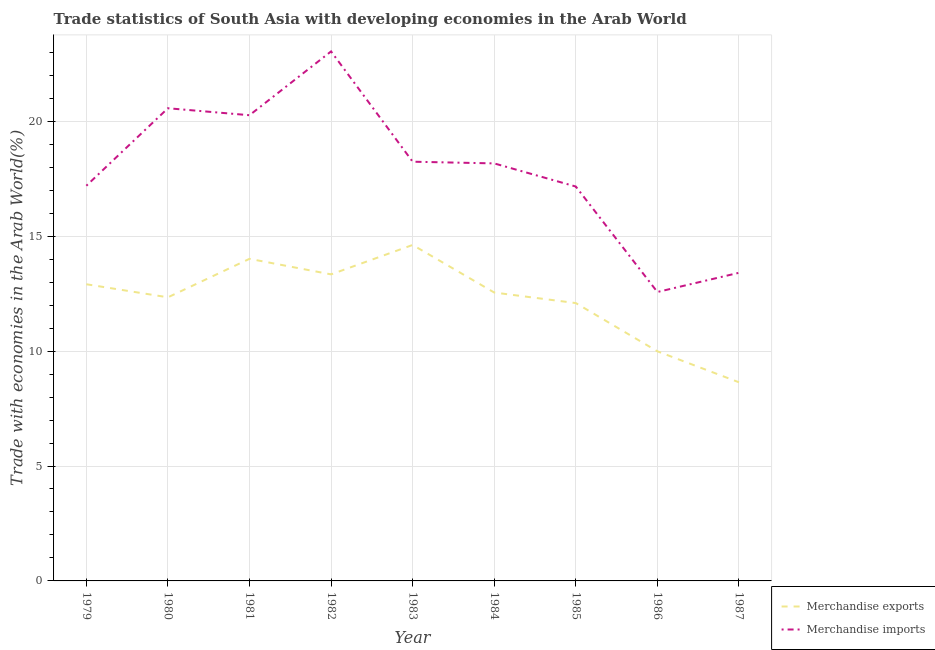Does the line corresponding to merchandise exports intersect with the line corresponding to merchandise imports?
Make the answer very short. No. Is the number of lines equal to the number of legend labels?
Your response must be concise. Yes. What is the merchandise imports in 1986?
Offer a very short reply. 12.57. Across all years, what is the maximum merchandise exports?
Ensure brevity in your answer.  14.62. Across all years, what is the minimum merchandise imports?
Offer a very short reply. 12.57. In which year was the merchandise exports minimum?
Your answer should be compact. 1987. What is the total merchandise imports in the graph?
Provide a succinct answer. 160.62. What is the difference between the merchandise exports in 1979 and that in 1984?
Offer a terse response. 0.36. What is the difference between the merchandise imports in 1985 and the merchandise exports in 1984?
Provide a succinct answer. 4.61. What is the average merchandise imports per year?
Keep it short and to the point. 17.85. In the year 1986, what is the difference between the merchandise exports and merchandise imports?
Ensure brevity in your answer.  -2.58. What is the ratio of the merchandise exports in 1984 to that in 1985?
Make the answer very short. 1.04. Is the merchandise exports in 1981 less than that in 1985?
Your answer should be very brief. No. What is the difference between the highest and the second highest merchandise imports?
Offer a very short reply. 2.47. What is the difference between the highest and the lowest merchandise exports?
Offer a very short reply. 5.98. In how many years, is the merchandise imports greater than the average merchandise imports taken over all years?
Provide a succinct answer. 5. Is the sum of the merchandise exports in 1981 and 1983 greater than the maximum merchandise imports across all years?
Offer a terse response. Yes. Is the merchandise exports strictly greater than the merchandise imports over the years?
Give a very brief answer. No. Is the merchandise exports strictly less than the merchandise imports over the years?
Your answer should be very brief. Yes. Are the values on the major ticks of Y-axis written in scientific E-notation?
Your response must be concise. No. What is the title of the graph?
Your response must be concise. Trade statistics of South Asia with developing economies in the Arab World. What is the label or title of the Y-axis?
Offer a terse response. Trade with economies in the Arab World(%). What is the Trade with economies in the Arab World(%) of Merchandise exports in 1979?
Provide a short and direct response. 12.91. What is the Trade with economies in the Arab World(%) of Merchandise imports in 1979?
Ensure brevity in your answer.  17.2. What is the Trade with economies in the Arab World(%) in Merchandise exports in 1980?
Provide a succinct answer. 12.34. What is the Trade with economies in the Arab World(%) in Merchandise imports in 1980?
Offer a terse response. 20.57. What is the Trade with economies in the Arab World(%) in Merchandise exports in 1981?
Provide a short and direct response. 14.02. What is the Trade with economies in the Arab World(%) of Merchandise imports in 1981?
Your answer should be compact. 20.26. What is the Trade with economies in the Arab World(%) in Merchandise exports in 1982?
Your answer should be compact. 13.34. What is the Trade with economies in the Arab World(%) of Merchandise imports in 1982?
Your response must be concise. 23.04. What is the Trade with economies in the Arab World(%) in Merchandise exports in 1983?
Provide a short and direct response. 14.62. What is the Trade with economies in the Arab World(%) of Merchandise imports in 1983?
Keep it short and to the point. 18.24. What is the Trade with economies in the Arab World(%) in Merchandise exports in 1984?
Your answer should be very brief. 12.55. What is the Trade with economies in the Arab World(%) in Merchandise imports in 1984?
Provide a short and direct response. 18.17. What is the Trade with economies in the Arab World(%) in Merchandise exports in 1985?
Your answer should be very brief. 12.09. What is the Trade with economies in the Arab World(%) of Merchandise imports in 1985?
Your response must be concise. 17.16. What is the Trade with economies in the Arab World(%) of Merchandise exports in 1986?
Your answer should be compact. 9.99. What is the Trade with economies in the Arab World(%) of Merchandise imports in 1986?
Offer a very short reply. 12.57. What is the Trade with economies in the Arab World(%) in Merchandise exports in 1987?
Ensure brevity in your answer.  8.64. What is the Trade with economies in the Arab World(%) of Merchandise imports in 1987?
Keep it short and to the point. 13.41. Across all years, what is the maximum Trade with economies in the Arab World(%) of Merchandise exports?
Your answer should be compact. 14.62. Across all years, what is the maximum Trade with economies in the Arab World(%) of Merchandise imports?
Provide a short and direct response. 23.04. Across all years, what is the minimum Trade with economies in the Arab World(%) of Merchandise exports?
Your answer should be compact. 8.64. Across all years, what is the minimum Trade with economies in the Arab World(%) of Merchandise imports?
Make the answer very short. 12.57. What is the total Trade with economies in the Arab World(%) in Merchandise exports in the graph?
Your response must be concise. 110.5. What is the total Trade with economies in the Arab World(%) in Merchandise imports in the graph?
Offer a very short reply. 160.62. What is the difference between the Trade with economies in the Arab World(%) in Merchandise exports in 1979 and that in 1980?
Your response must be concise. 0.57. What is the difference between the Trade with economies in the Arab World(%) of Merchandise imports in 1979 and that in 1980?
Offer a terse response. -3.37. What is the difference between the Trade with economies in the Arab World(%) of Merchandise exports in 1979 and that in 1981?
Your response must be concise. -1.11. What is the difference between the Trade with economies in the Arab World(%) in Merchandise imports in 1979 and that in 1981?
Offer a very short reply. -3.07. What is the difference between the Trade with economies in the Arab World(%) in Merchandise exports in 1979 and that in 1982?
Provide a succinct answer. -0.43. What is the difference between the Trade with economies in the Arab World(%) of Merchandise imports in 1979 and that in 1982?
Ensure brevity in your answer.  -5.85. What is the difference between the Trade with economies in the Arab World(%) of Merchandise exports in 1979 and that in 1983?
Your answer should be compact. -1.71. What is the difference between the Trade with economies in the Arab World(%) of Merchandise imports in 1979 and that in 1983?
Give a very brief answer. -1.05. What is the difference between the Trade with economies in the Arab World(%) in Merchandise exports in 1979 and that in 1984?
Your answer should be very brief. 0.36. What is the difference between the Trade with economies in the Arab World(%) in Merchandise imports in 1979 and that in 1984?
Make the answer very short. -0.97. What is the difference between the Trade with economies in the Arab World(%) in Merchandise exports in 1979 and that in 1985?
Your answer should be very brief. 0.82. What is the difference between the Trade with economies in the Arab World(%) in Merchandise imports in 1979 and that in 1985?
Give a very brief answer. 0.03. What is the difference between the Trade with economies in the Arab World(%) in Merchandise exports in 1979 and that in 1986?
Give a very brief answer. 2.92. What is the difference between the Trade with economies in the Arab World(%) in Merchandise imports in 1979 and that in 1986?
Offer a very short reply. 4.62. What is the difference between the Trade with economies in the Arab World(%) of Merchandise exports in 1979 and that in 1987?
Give a very brief answer. 4.27. What is the difference between the Trade with economies in the Arab World(%) of Merchandise imports in 1979 and that in 1987?
Your answer should be compact. 3.79. What is the difference between the Trade with economies in the Arab World(%) of Merchandise exports in 1980 and that in 1981?
Keep it short and to the point. -1.67. What is the difference between the Trade with economies in the Arab World(%) in Merchandise imports in 1980 and that in 1981?
Your answer should be very brief. 0.3. What is the difference between the Trade with economies in the Arab World(%) in Merchandise exports in 1980 and that in 1982?
Your response must be concise. -1. What is the difference between the Trade with economies in the Arab World(%) of Merchandise imports in 1980 and that in 1982?
Give a very brief answer. -2.47. What is the difference between the Trade with economies in the Arab World(%) in Merchandise exports in 1980 and that in 1983?
Your response must be concise. -2.28. What is the difference between the Trade with economies in the Arab World(%) of Merchandise imports in 1980 and that in 1983?
Keep it short and to the point. 2.33. What is the difference between the Trade with economies in the Arab World(%) of Merchandise exports in 1980 and that in 1984?
Provide a succinct answer. -0.21. What is the difference between the Trade with economies in the Arab World(%) of Merchandise imports in 1980 and that in 1984?
Provide a succinct answer. 2.4. What is the difference between the Trade with economies in the Arab World(%) of Merchandise exports in 1980 and that in 1985?
Give a very brief answer. 0.25. What is the difference between the Trade with economies in the Arab World(%) of Merchandise imports in 1980 and that in 1985?
Provide a succinct answer. 3.41. What is the difference between the Trade with economies in the Arab World(%) in Merchandise exports in 1980 and that in 1986?
Offer a terse response. 2.35. What is the difference between the Trade with economies in the Arab World(%) of Merchandise imports in 1980 and that in 1986?
Your answer should be very brief. 8. What is the difference between the Trade with economies in the Arab World(%) in Merchandise exports in 1980 and that in 1987?
Provide a short and direct response. 3.7. What is the difference between the Trade with economies in the Arab World(%) of Merchandise imports in 1980 and that in 1987?
Keep it short and to the point. 7.16. What is the difference between the Trade with economies in the Arab World(%) in Merchandise exports in 1981 and that in 1982?
Make the answer very short. 0.68. What is the difference between the Trade with economies in the Arab World(%) of Merchandise imports in 1981 and that in 1982?
Ensure brevity in your answer.  -2.78. What is the difference between the Trade with economies in the Arab World(%) of Merchandise exports in 1981 and that in 1983?
Your answer should be very brief. -0.6. What is the difference between the Trade with economies in the Arab World(%) in Merchandise imports in 1981 and that in 1983?
Your answer should be very brief. 2.02. What is the difference between the Trade with economies in the Arab World(%) of Merchandise exports in 1981 and that in 1984?
Provide a short and direct response. 1.47. What is the difference between the Trade with economies in the Arab World(%) of Merchandise imports in 1981 and that in 1984?
Provide a succinct answer. 2.1. What is the difference between the Trade with economies in the Arab World(%) of Merchandise exports in 1981 and that in 1985?
Provide a short and direct response. 1.93. What is the difference between the Trade with economies in the Arab World(%) in Merchandise imports in 1981 and that in 1985?
Provide a succinct answer. 3.1. What is the difference between the Trade with economies in the Arab World(%) in Merchandise exports in 1981 and that in 1986?
Provide a short and direct response. 4.02. What is the difference between the Trade with economies in the Arab World(%) in Merchandise imports in 1981 and that in 1986?
Your answer should be very brief. 7.69. What is the difference between the Trade with economies in the Arab World(%) in Merchandise exports in 1981 and that in 1987?
Give a very brief answer. 5.37. What is the difference between the Trade with economies in the Arab World(%) of Merchandise imports in 1981 and that in 1987?
Ensure brevity in your answer.  6.86. What is the difference between the Trade with economies in the Arab World(%) of Merchandise exports in 1982 and that in 1983?
Make the answer very short. -1.28. What is the difference between the Trade with economies in the Arab World(%) of Merchandise imports in 1982 and that in 1983?
Keep it short and to the point. 4.8. What is the difference between the Trade with economies in the Arab World(%) in Merchandise exports in 1982 and that in 1984?
Provide a short and direct response. 0.79. What is the difference between the Trade with economies in the Arab World(%) of Merchandise imports in 1982 and that in 1984?
Provide a succinct answer. 4.87. What is the difference between the Trade with economies in the Arab World(%) in Merchandise exports in 1982 and that in 1985?
Your answer should be compact. 1.25. What is the difference between the Trade with economies in the Arab World(%) in Merchandise imports in 1982 and that in 1985?
Give a very brief answer. 5.88. What is the difference between the Trade with economies in the Arab World(%) of Merchandise exports in 1982 and that in 1986?
Keep it short and to the point. 3.35. What is the difference between the Trade with economies in the Arab World(%) in Merchandise imports in 1982 and that in 1986?
Provide a succinct answer. 10.47. What is the difference between the Trade with economies in the Arab World(%) in Merchandise exports in 1982 and that in 1987?
Offer a very short reply. 4.7. What is the difference between the Trade with economies in the Arab World(%) of Merchandise imports in 1982 and that in 1987?
Your response must be concise. 9.63. What is the difference between the Trade with economies in the Arab World(%) in Merchandise exports in 1983 and that in 1984?
Provide a succinct answer. 2.07. What is the difference between the Trade with economies in the Arab World(%) of Merchandise imports in 1983 and that in 1984?
Your answer should be compact. 0.07. What is the difference between the Trade with economies in the Arab World(%) in Merchandise exports in 1983 and that in 1985?
Give a very brief answer. 2.53. What is the difference between the Trade with economies in the Arab World(%) of Merchandise imports in 1983 and that in 1985?
Provide a succinct answer. 1.08. What is the difference between the Trade with economies in the Arab World(%) in Merchandise exports in 1983 and that in 1986?
Make the answer very short. 4.63. What is the difference between the Trade with economies in the Arab World(%) in Merchandise imports in 1983 and that in 1986?
Offer a terse response. 5.67. What is the difference between the Trade with economies in the Arab World(%) of Merchandise exports in 1983 and that in 1987?
Your answer should be compact. 5.98. What is the difference between the Trade with economies in the Arab World(%) in Merchandise imports in 1983 and that in 1987?
Make the answer very short. 4.83. What is the difference between the Trade with economies in the Arab World(%) in Merchandise exports in 1984 and that in 1985?
Offer a terse response. 0.46. What is the difference between the Trade with economies in the Arab World(%) of Merchandise imports in 1984 and that in 1985?
Provide a succinct answer. 1.01. What is the difference between the Trade with economies in the Arab World(%) in Merchandise exports in 1984 and that in 1986?
Keep it short and to the point. 2.56. What is the difference between the Trade with economies in the Arab World(%) of Merchandise imports in 1984 and that in 1986?
Provide a short and direct response. 5.6. What is the difference between the Trade with economies in the Arab World(%) of Merchandise exports in 1984 and that in 1987?
Provide a succinct answer. 3.91. What is the difference between the Trade with economies in the Arab World(%) of Merchandise imports in 1984 and that in 1987?
Offer a very short reply. 4.76. What is the difference between the Trade with economies in the Arab World(%) in Merchandise exports in 1985 and that in 1986?
Offer a terse response. 2.1. What is the difference between the Trade with economies in the Arab World(%) in Merchandise imports in 1985 and that in 1986?
Provide a short and direct response. 4.59. What is the difference between the Trade with economies in the Arab World(%) of Merchandise exports in 1985 and that in 1987?
Ensure brevity in your answer.  3.45. What is the difference between the Trade with economies in the Arab World(%) of Merchandise imports in 1985 and that in 1987?
Offer a very short reply. 3.75. What is the difference between the Trade with economies in the Arab World(%) in Merchandise exports in 1986 and that in 1987?
Offer a very short reply. 1.35. What is the difference between the Trade with economies in the Arab World(%) in Merchandise imports in 1986 and that in 1987?
Your response must be concise. -0.84. What is the difference between the Trade with economies in the Arab World(%) in Merchandise exports in 1979 and the Trade with economies in the Arab World(%) in Merchandise imports in 1980?
Your answer should be compact. -7.66. What is the difference between the Trade with economies in the Arab World(%) in Merchandise exports in 1979 and the Trade with economies in the Arab World(%) in Merchandise imports in 1981?
Give a very brief answer. -7.36. What is the difference between the Trade with economies in the Arab World(%) in Merchandise exports in 1979 and the Trade with economies in the Arab World(%) in Merchandise imports in 1982?
Your answer should be very brief. -10.13. What is the difference between the Trade with economies in the Arab World(%) of Merchandise exports in 1979 and the Trade with economies in the Arab World(%) of Merchandise imports in 1983?
Your answer should be very brief. -5.33. What is the difference between the Trade with economies in the Arab World(%) in Merchandise exports in 1979 and the Trade with economies in the Arab World(%) in Merchandise imports in 1984?
Ensure brevity in your answer.  -5.26. What is the difference between the Trade with economies in the Arab World(%) of Merchandise exports in 1979 and the Trade with economies in the Arab World(%) of Merchandise imports in 1985?
Offer a terse response. -4.25. What is the difference between the Trade with economies in the Arab World(%) in Merchandise exports in 1979 and the Trade with economies in the Arab World(%) in Merchandise imports in 1986?
Your answer should be compact. 0.34. What is the difference between the Trade with economies in the Arab World(%) in Merchandise exports in 1979 and the Trade with economies in the Arab World(%) in Merchandise imports in 1987?
Provide a short and direct response. -0.5. What is the difference between the Trade with economies in the Arab World(%) of Merchandise exports in 1980 and the Trade with economies in the Arab World(%) of Merchandise imports in 1981?
Give a very brief answer. -7.92. What is the difference between the Trade with economies in the Arab World(%) of Merchandise exports in 1980 and the Trade with economies in the Arab World(%) of Merchandise imports in 1982?
Your answer should be compact. -10.7. What is the difference between the Trade with economies in the Arab World(%) of Merchandise exports in 1980 and the Trade with economies in the Arab World(%) of Merchandise imports in 1983?
Your answer should be compact. -5.9. What is the difference between the Trade with economies in the Arab World(%) of Merchandise exports in 1980 and the Trade with economies in the Arab World(%) of Merchandise imports in 1984?
Offer a very short reply. -5.83. What is the difference between the Trade with economies in the Arab World(%) of Merchandise exports in 1980 and the Trade with economies in the Arab World(%) of Merchandise imports in 1985?
Give a very brief answer. -4.82. What is the difference between the Trade with economies in the Arab World(%) of Merchandise exports in 1980 and the Trade with economies in the Arab World(%) of Merchandise imports in 1986?
Give a very brief answer. -0.23. What is the difference between the Trade with economies in the Arab World(%) in Merchandise exports in 1980 and the Trade with economies in the Arab World(%) in Merchandise imports in 1987?
Your answer should be compact. -1.07. What is the difference between the Trade with economies in the Arab World(%) in Merchandise exports in 1981 and the Trade with economies in the Arab World(%) in Merchandise imports in 1982?
Your answer should be compact. -9.03. What is the difference between the Trade with economies in the Arab World(%) of Merchandise exports in 1981 and the Trade with economies in the Arab World(%) of Merchandise imports in 1983?
Your answer should be compact. -4.23. What is the difference between the Trade with economies in the Arab World(%) of Merchandise exports in 1981 and the Trade with economies in the Arab World(%) of Merchandise imports in 1984?
Your answer should be very brief. -4.15. What is the difference between the Trade with economies in the Arab World(%) in Merchandise exports in 1981 and the Trade with economies in the Arab World(%) in Merchandise imports in 1985?
Make the answer very short. -3.15. What is the difference between the Trade with economies in the Arab World(%) in Merchandise exports in 1981 and the Trade with economies in the Arab World(%) in Merchandise imports in 1986?
Ensure brevity in your answer.  1.44. What is the difference between the Trade with economies in the Arab World(%) of Merchandise exports in 1981 and the Trade with economies in the Arab World(%) of Merchandise imports in 1987?
Your answer should be compact. 0.61. What is the difference between the Trade with economies in the Arab World(%) of Merchandise exports in 1982 and the Trade with economies in the Arab World(%) of Merchandise imports in 1983?
Give a very brief answer. -4.9. What is the difference between the Trade with economies in the Arab World(%) in Merchandise exports in 1982 and the Trade with economies in the Arab World(%) in Merchandise imports in 1984?
Your answer should be very brief. -4.83. What is the difference between the Trade with economies in the Arab World(%) in Merchandise exports in 1982 and the Trade with economies in the Arab World(%) in Merchandise imports in 1985?
Make the answer very short. -3.82. What is the difference between the Trade with economies in the Arab World(%) of Merchandise exports in 1982 and the Trade with economies in the Arab World(%) of Merchandise imports in 1986?
Ensure brevity in your answer.  0.77. What is the difference between the Trade with economies in the Arab World(%) in Merchandise exports in 1982 and the Trade with economies in the Arab World(%) in Merchandise imports in 1987?
Offer a terse response. -0.07. What is the difference between the Trade with economies in the Arab World(%) of Merchandise exports in 1983 and the Trade with economies in the Arab World(%) of Merchandise imports in 1984?
Give a very brief answer. -3.55. What is the difference between the Trade with economies in the Arab World(%) in Merchandise exports in 1983 and the Trade with economies in the Arab World(%) in Merchandise imports in 1985?
Make the answer very short. -2.54. What is the difference between the Trade with economies in the Arab World(%) of Merchandise exports in 1983 and the Trade with economies in the Arab World(%) of Merchandise imports in 1986?
Provide a succinct answer. 2.05. What is the difference between the Trade with economies in the Arab World(%) in Merchandise exports in 1983 and the Trade with economies in the Arab World(%) in Merchandise imports in 1987?
Offer a terse response. 1.21. What is the difference between the Trade with economies in the Arab World(%) in Merchandise exports in 1984 and the Trade with economies in the Arab World(%) in Merchandise imports in 1985?
Your answer should be compact. -4.61. What is the difference between the Trade with economies in the Arab World(%) of Merchandise exports in 1984 and the Trade with economies in the Arab World(%) of Merchandise imports in 1986?
Make the answer very short. -0.02. What is the difference between the Trade with economies in the Arab World(%) of Merchandise exports in 1984 and the Trade with economies in the Arab World(%) of Merchandise imports in 1987?
Offer a terse response. -0.86. What is the difference between the Trade with economies in the Arab World(%) of Merchandise exports in 1985 and the Trade with economies in the Arab World(%) of Merchandise imports in 1986?
Offer a very short reply. -0.48. What is the difference between the Trade with economies in the Arab World(%) of Merchandise exports in 1985 and the Trade with economies in the Arab World(%) of Merchandise imports in 1987?
Your response must be concise. -1.32. What is the difference between the Trade with economies in the Arab World(%) in Merchandise exports in 1986 and the Trade with economies in the Arab World(%) in Merchandise imports in 1987?
Ensure brevity in your answer.  -3.42. What is the average Trade with economies in the Arab World(%) of Merchandise exports per year?
Your response must be concise. 12.28. What is the average Trade with economies in the Arab World(%) in Merchandise imports per year?
Your answer should be very brief. 17.85. In the year 1979, what is the difference between the Trade with economies in the Arab World(%) of Merchandise exports and Trade with economies in the Arab World(%) of Merchandise imports?
Your answer should be compact. -4.29. In the year 1980, what is the difference between the Trade with economies in the Arab World(%) of Merchandise exports and Trade with economies in the Arab World(%) of Merchandise imports?
Ensure brevity in your answer.  -8.23. In the year 1981, what is the difference between the Trade with economies in the Arab World(%) in Merchandise exports and Trade with economies in the Arab World(%) in Merchandise imports?
Keep it short and to the point. -6.25. In the year 1982, what is the difference between the Trade with economies in the Arab World(%) in Merchandise exports and Trade with economies in the Arab World(%) in Merchandise imports?
Offer a terse response. -9.7. In the year 1983, what is the difference between the Trade with economies in the Arab World(%) in Merchandise exports and Trade with economies in the Arab World(%) in Merchandise imports?
Your answer should be compact. -3.62. In the year 1984, what is the difference between the Trade with economies in the Arab World(%) of Merchandise exports and Trade with economies in the Arab World(%) of Merchandise imports?
Make the answer very short. -5.62. In the year 1985, what is the difference between the Trade with economies in the Arab World(%) in Merchandise exports and Trade with economies in the Arab World(%) in Merchandise imports?
Your answer should be compact. -5.07. In the year 1986, what is the difference between the Trade with economies in the Arab World(%) in Merchandise exports and Trade with economies in the Arab World(%) in Merchandise imports?
Give a very brief answer. -2.58. In the year 1987, what is the difference between the Trade with economies in the Arab World(%) in Merchandise exports and Trade with economies in the Arab World(%) in Merchandise imports?
Give a very brief answer. -4.76. What is the ratio of the Trade with economies in the Arab World(%) of Merchandise exports in 1979 to that in 1980?
Ensure brevity in your answer.  1.05. What is the ratio of the Trade with economies in the Arab World(%) in Merchandise imports in 1979 to that in 1980?
Give a very brief answer. 0.84. What is the ratio of the Trade with economies in the Arab World(%) of Merchandise exports in 1979 to that in 1981?
Give a very brief answer. 0.92. What is the ratio of the Trade with economies in the Arab World(%) in Merchandise imports in 1979 to that in 1981?
Make the answer very short. 0.85. What is the ratio of the Trade with economies in the Arab World(%) in Merchandise exports in 1979 to that in 1982?
Make the answer very short. 0.97. What is the ratio of the Trade with economies in the Arab World(%) of Merchandise imports in 1979 to that in 1982?
Offer a terse response. 0.75. What is the ratio of the Trade with economies in the Arab World(%) in Merchandise exports in 1979 to that in 1983?
Keep it short and to the point. 0.88. What is the ratio of the Trade with economies in the Arab World(%) of Merchandise imports in 1979 to that in 1983?
Offer a very short reply. 0.94. What is the ratio of the Trade with economies in the Arab World(%) in Merchandise exports in 1979 to that in 1984?
Your answer should be compact. 1.03. What is the ratio of the Trade with economies in the Arab World(%) of Merchandise imports in 1979 to that in 1984?
Your answer should be compact. 0.95. What is the ratio of the Trade with economies in the Arab World(%) in Merchandise exports in 1979 to that in 1985?
Keep it short and to the point. 1.07. What is the ratio of the Trade with economies in the Arab World(%) in Merchandise imports in 1979 to that in 1985?
Provide a short and direct response. 1. What is the ratio of the Trade with economies in the Arab World(%) in Merchandise exports in 1979 to that in 1986?
Offer a very short reply. 1.29. What is the ratio of the Trade with economies in the Arab World(%) of Merchandise imports in 1979 to that in 1986?
Make the answer very short. 1.37. What is the ratio of the Trade with economies in the Arab World(%) of Merchandise exports in 1979 to that in 1987?
Ensure brevity in your answer.  1.49. What is the ratio of the Trade with economies in the Arab World(%) of Merchandise imports in 1979 to that in 1987?
Offer a very short reply. 1.28. What is the ratio of the Trade with economies in the Arab World(%) in Merchandise exports in 1980 to that in 1981?
Your response must be concise. 0.88. What is the ratio of the Trade with economies in the Arab World(%) of Merchandise exports in 1980 to that in 1982?
Keep it short and to the point. 0.93. What is the ratio of the Trade with economies in the Arab World(%) of Merchandise imports in 1980 to that in 1982?
Provide a succinct answer. 0.89. What is the ratio of the Trade with economies in the Arab World(%) of Merchandise exports in 1980 to that in 1983?
Provide a succinct answer. 0.84. What is the ratio of the Trade with economies in the Arab World(%) in Merchandise imports in 1980 to that in 1983?
Offer a very short reply. 1.13. What is the ratio of the Trade with economies in the Arab World(%) in Merchandise exports in 1980 to that in 1984?
Your answer should be very brief. 0.98. What is the ratio of the Trade with economies in the Arab World(%) in Merchandise imports in 1980 to that in 1984?
Provide a succinct answer. 1.13. What is the ratio of the Trade with economies in the Arab World(%) of Merchandise exports in 1980 to that in 1985?
Offer a terse response. 1.02. What is the ratio of the Trade with economies in the Arab World(%) of Merchandise imports in 1980 to that in 1985?
Ensure brevity in your answer.  1.2. What is the ratio of the Trade with economies in the Arab World(%) in Merchandise exports in 1980 to that in 1986?
Your answer should be compact. 1.24. What is the ratio of the Trade with economies in the Arab World(%) in Merchandise imports in 1980 to that in 1986?
Your response must be concise. 1.64. What is the ratio of the Trade with economies in the Arab World(%) of Merchandise exports in 1980 to that in 1987?
Offer a very short reply. 1.43. What is the ratio of the Trade with economies in the Arab World(%) in Merchandise imports in 1980 to that in 1987?
Provide a succinct answer. 1.53. What is the ratio of the Trade with economies in the Arab World(%) in Merchandise exports in 1981 to that in 1982?
Your response must be concise. 1.05. What is the ratio of the Trade with economies in the Arab World(%) in Merchandise imports in 1981 to that in 1982?
Provide a short and direct response. 0.88. What is the ratio of the Trade with economies in the Arab World(%) of Merchandise exports in 1981 to that in 1983?
Provide a succinct answer. 0.96. What is the ratio of the Trade with economies in the Arab World(%) in Merchandise imports in 1981 to that in 1983?
Offer a terse response. 1.11. What is the ratio of the Trade with economies in the Arab World(%) of Merchandise exports in 1981 to that in 1984?
Provide a short and direct response. 1.12. What is the ratio of the Trade with economies in the Arab World(%) in Merchandise imports in 1981 to that in 1984?
Provide a short and direct response. 1.12. What is the ratio of the Trade with economies in the Arab World(%) of Merchandise exports in 1981 to that in 1985?
Offer a terse response. 1.16. What is the ratio of the Trade with economies in the Arab World(%) in Merchandise imports in 1981 to that in 1985?
Give a very brief answer. 1.18. What is the ratio of the Trade with economies in the Arab World(%) of Merchandise exports in 1981 to that in 1986?
Offer a very short reply. 1.4. What is the ratio of the Trade with economies in the Arab World(%) in Merchandise imports in 1981 to that in 1986?
Give a very brief answer. 1.61. What is the ratio of the Trade with economies in the Arab World(%) in Merchandise exports in 1981 to that in 1987?
Your response must be concise. 1.62. What is the ratio of the Trade with economies in the Arab World(%) of Merchandise imports in 1981 to that in 1987?
Provide a succinct answer. 1.51. What is the ratio of the Trade with economies in the Arab World(%) in Merchandise exports in 1982 to that in 1983?
Give a very brief answer. 0.91. What is the ratio of the Trade with economies in the Arab World(%) of Merchandise imports in 1982 to that in 1983?
Give a very brief answer. 1.26. What is the ratio of the Trade with economies in the Arab World(%) of Merchandise exports in 1982 to that in 1984?
Ensure brevity in your answer.  1.06. What is the ratio of the Trade with economies in the Arab World(%) in Merchandise imports in 1982 to that in 1984?
Your response must be concise. 1.27. What is the ratio of the Trade with economies in the Arab World(%) in Merchandise exports in 1982 to that in 1985?
Your answer should be compact. 1.1. What is the ratio of the Trade with economies in the Arab World(%) of Merchandise imports in 1982 to that in 1985?
Give a very brief answer. 1.34. What is the ratio of the Trade with economies in the Arab World(%) of Merchandise exports in 1982 to that in 1986?
Offer a very short reply. 1.33. What is the ratio of the Trade with economies in the Arab World(%) in Merchandise imports in 1982 to that in 1986?
Keep it short and to the point. 1.83. What is the ratio of the Trade with economies in the Arab World(%) in Merchandise exports in 1982 to that in 1987?
Ensure brevity in your answer.  1.54. What is the ratio of the Trade with economies in the Arab World(%) in Merchandise imports in 1982 to that in 1987?
Provide a succinct answer. 1.72. What is the ratio of the Trade with economies in the Arab World(%) in Merchandise exports in 1983 to that in 1984?
Provide a succinct answer. 1.17. What is the ratio of the Trade with economies in the Arab World(%) in Merchandise imports in 1983 to that in 1984?
Give a very brief answer. 1. What is the ratio of the Trade with economies in the Arab World(%) of Merchandise exports in 1983 to that in 1985?
Make the answer very short. 1.21. What is the ratio of the Trade with economies in the Arab World(%) of Merchandise imports in 1983 to that in 1985?
Give a very brief answer. 1.06. What is the ratio of the Trade with economies in the Arab World(%) of Merchandise exports in 1983 to that in 1986?
Offer a very short reply. 1.46. What is the ratio of the Trade with economies in the Arab World(%) in Merchandise imports in 1983 to that in 1986?
Your answer should be very brief. 1.45. What is the ratio of the Trade with economies in the Arab World(%) of Merchandise exports in 1983 to that in 1987?
Provide a succinct answer. 1.69. What is the ratio of the Trade with economies in the Arab World(%) in Merchandise imports in 1983 to that in 1987?
Make the answer very short. 1.36. What is the ratio of the Trade with economies in the Arab World(%) in Merchandise exports in 1984 to that in 1985?
Give a very brief answer. 1.04. What is the ratio of the Trade with economies in the Arab World(%) of Merchandise imports in 1984 to that in 1985?
Offer a very short reply. 1.06. What is the ratio of the Trade with economies in the Arab World(%) in Merchandise exports in 1984 to that in 1986?
Offer a terse response. 1.26. What is the ratio of the Trade with economies in the Arab World(%) in Merchandise imports in 1984 to that in 1986?
Your response must be concise. 1.45. What is the ratio of the Trade with economies in the Arab World(%) in Merchandise exports in 1984 to that in 1987?
Your answer should be very brief. 1.45. What is the ratio of the Trade with economies in the Arab World(%) of Merchandise imports in 1984 to that in 1987?
Make the answer very short. 1.35. What is the ratio of the Trade with economies in the Arab World(%) in Merchandise exports in 1985 to that in 1986?
Offer a terse response. 1.21. What is the ratio of the Trade with economies in the Arab World(%) of Merchandise imports in 1985 to that in 1986?
Ensure brevity in your answer.  1.36. What is the ratio of the Trade with economies in the Arab World(%) in Merchandise exports in 1985 to that in 1987?
Provide a succinct answer. 1.4. What is the ratio of the Trade with economies in the Arab World(%) of Merchandise imports in 1985 to that in 1987?
Provide a short and direct response. 1.28. What is the ratio of the Trade with economies in the Arab World(%) of Merchandise exports in 1986 to that in 1987?
Ensure brevity in your answer.  1.16. What is the ratio of the Trade with economies in the Arab World(%) of Merchandise imports in 1986 to that in 1987?
Offer a very short reply. 0.94. What is the difference between the highest and the second highest Trade with economies in the Arab World(%) of Merchandise exports?
Ensure brevity in your answer.  0.6. What is the difference between the highest and the second highest Trade with economies in the Arab World(%) in Merchandise imports?
Make the answer very short. 2.47. What is the difference between the highest and the lowest Trade with economies in the Arab World(%) in Merchandise exports?
Ensure brevity in your answer.  5.98. What is the difference between the highest and the lowest Trade with economies in the Arab World(%) of Merchandise imports?
Make the answer very short. 10.47. 